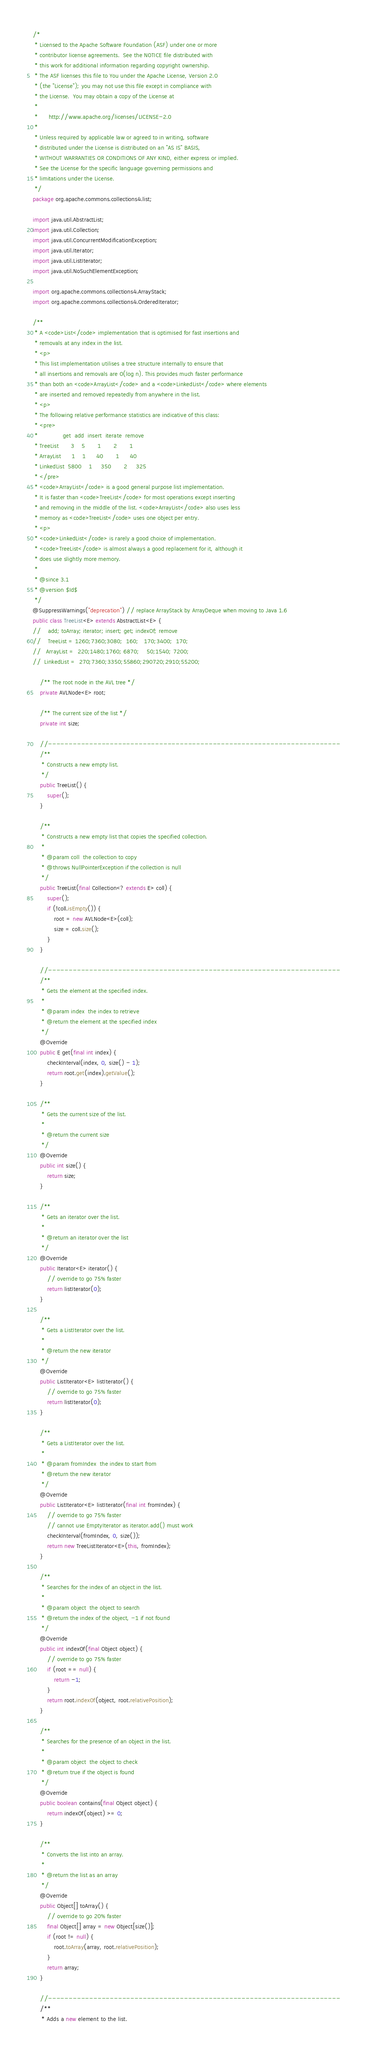Convert code to text. <code><loc_0><loc_0><loc_500><loc_500><_Java_>/*
 * Licensed to the Apache Software Foundation (ASF) under one or more
 * contributor license agreements.  See the NOTICE file distributed with
 * this work for additional information regarding copyright ownership.
 * The ASF licenses this file to You under the Apache License, Version 2.0
 * (the "License"); you may not use this file except in compliance with
 * the License.  You may obtain a copy of the License at
 *
 *      http://www.apache.org/licenses/LICENSE-2.0
 *
 * Unless required by applicable law or agreed to in writing, software
 * distributed under the License is distributed on an "AS IS" BASIS,
 * WITHOUT WARRANTIES OR CONDITIONS OF ANY KIND, either express or implied.
 * See the License for the specific language governing permissions and
 * limitations under the License.
 */
package org.apache.commons.collections4.list;

import java.util.AbstractList;
import java.util.Collection;
import java.util.ConcurrentModificationException;
import java.util.Iterator;
import java.util.ListIterator;
import java.util.NoSuchElementException;

import org.apache.commons.collections4.ArrayStack;
import org.apache.commons.collections4.OrderedIterator;

/**
 * A <code>List</code> implementation that is optimised for fast insertions and
 * removals at any index in the list.
 * <p>
 * This list implementation utilises a tree structure internally to ensure that
 * all insertions and removals are O(log n). This provides much faster performance
 * than both an <code>ArrayList</code> and a <code>LinkedList</code> where elements
 * are inserted and removed repeatedly from anywhere in the list.
 * <p>
 * The following relative performance statistics are indicative of this class:
 * <pre>
 *              get  add  insert  iterate  remove
 * TreeList       3    5       1       2       1
 * ArrayList      1    1      40       1      40
 * LinkedList  5800    1     350       2     325
 * </pre>
 * <code>ArrayList</code> is a good general purpose list implementation.
 * It is faster than <code>TreeList</code> for most operations except inserting
 * and removing in the middle of the list. <code>ArrayList</code> also uses less
 * memory as <code>TreeList</code> uses one object per entry.
 * <p>
 * <code>LinkedList</code> is rarely a good choice of implementation.
 * <code>TreeList</code> is almost always a good replacement for it, although it
 * does use slightly more memory.
 *
 * @since 3.1
 * @version $Id$
 */
@SuppressWarnings("deprecation") // replace ArrayStack by ArrayDeque when moving to Java 1.6
public class TreeList<E> extends AbstractList<E> {
//    add; toArray; iterator; insert; get; indexOf; remove
//    TreeList = 1260;7360;3080;  160;   170;3400;  170;
//   ArrayList =  220;1480;1760; 6870;    50;1540; 7200;
//  LinkedList =  270;7360;3350;55860;290720;2910;55200;

    /** The root node in the AVL tree */
    private AVLNode<E> root;

    /** The current size of the list */
    private int size;

    //-----------------------------------------------------------------------
    /**
     * Constructs a new empty list.
     */
    public TreeList() {
        super();
    }

    /**
     * Constructs a new empty list that copies the specified collection.
     *
     * @param coll  the collection to copy
     * @throws NullPointerException if the collection is null
     */
    public TreeList(final Collection<? extends E> coll) {
        super();
        if (!coll.isEmpty()) {
            root = new AVLNode<E>(coll);
            size = coll.size();
        }
    }

    //-----------------------------------------------------------------------
    /**
     * Gets the element at the specified index.
     *
     * @param index  the index to retrieve
     * @return the element at the specified index
     */
    @Override
    public E get(final int index) {
        checkInterval(index, 0, size() - 1);
        return root.get(index).getValue();
    }

    /**
     * Gets the current size of the list.
     *
     * @return the current size
     */
    @Override
    public int size() {
        return size;
    }

    /**
     * Gets an iterator over the list.
     *
     * @return an iterator over the list
     */
    @Override
    public Iterator<E> iterator() {
        // override to go 75% faster
        return listIterator(0);
    }

    /**
     * Gets a ListIterator over the list.
     *
     * @return the new iterator
     */
    @Override
    public ListIterator<E> listIterator() {
        // override to go 75% faster
        return listIterator(0);
    }

    /**
     * Gets a ListIterator over the list.
     *
     * @param fromIndex  the index to start from
     * @return the new iterator
     */
    @Override
    public ListIterator<E> listIterator(final int fromIndex) {
        // override to go 75% faster
        // cannot use EmptyIterator as iterator.add() must work
        checkInterval(fromIndex, 0, size());
        return new TreeListIterator<E>(this, fromIndex);
    }

    /**
     * Searches for the index of an object in the list.
     *
     * @param object  the object to search
     * @return the index of the object, -1 if not found
     */
    @Override
    public int indexOf(final Object object) {
        // override to go 75% faster
        if (root == null) {
            return -1;
        }
        return root.indexOf(object, root.relativePosition);
    }

    /**
     * Searches for the presence of an object in the list.
     *
     * @param object  the object to check
     * @return true if the object is found
     */
    @Override
    public boolean contains(final Object object) {
        return indexOf(object) >= 0;
    }

    /**
     * Converts the list into an array.
     *
     * @return the list as an array
     */
    @Override
    public Object[] toArray() {
        // override to go 20% faster
        final Object[] array = new Object[size()];
        if (root != null) {
            root.toArray(array, root.relativePosition);
        }
        return array;
    }

    //-----------------------------------------------------------------------
    /**
     * Adds a new element to the list.</code> 